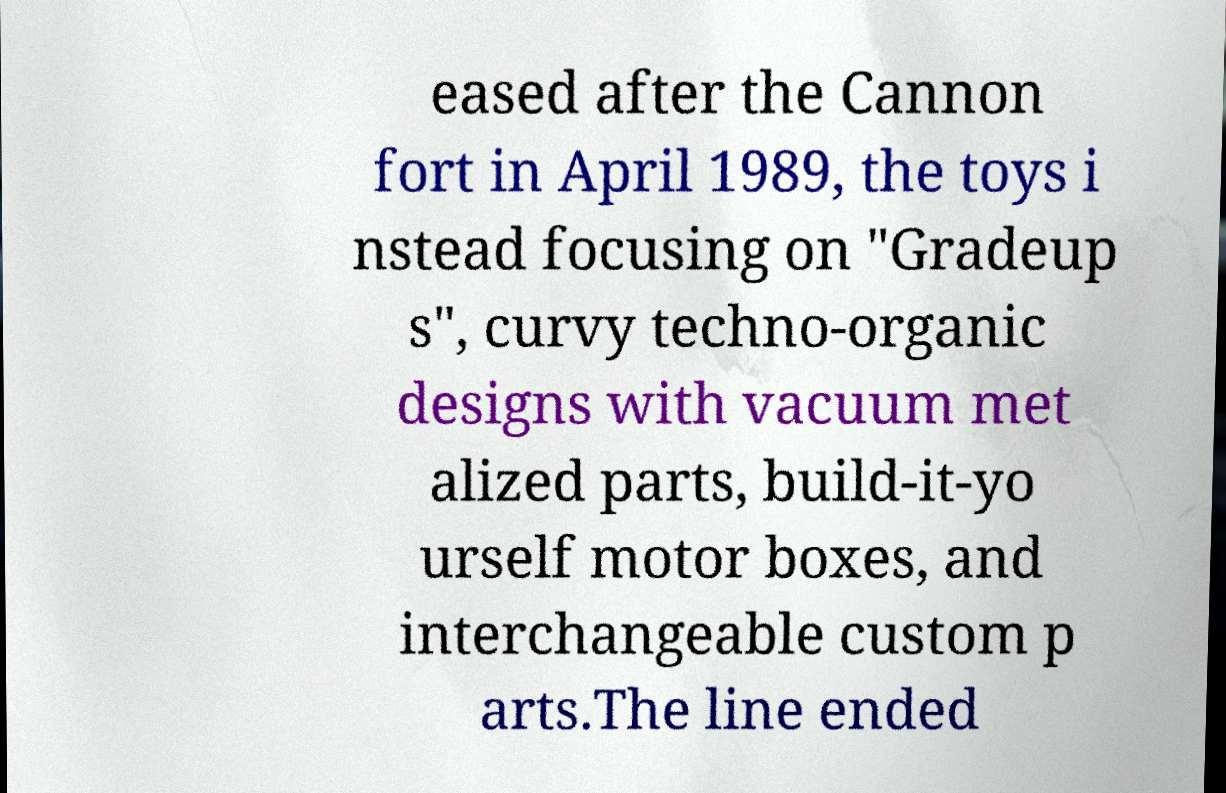Could you assist in decoding the text presented in this image and type it out clearly? eased after the Cannon fort in April 1989, the toys i nstead focusing on "Gradeup s", curvy techno-organic designs with vacuum met alized parts, build-it-yo urself motor boxes, and interchangeable custom p arts.The line ended 